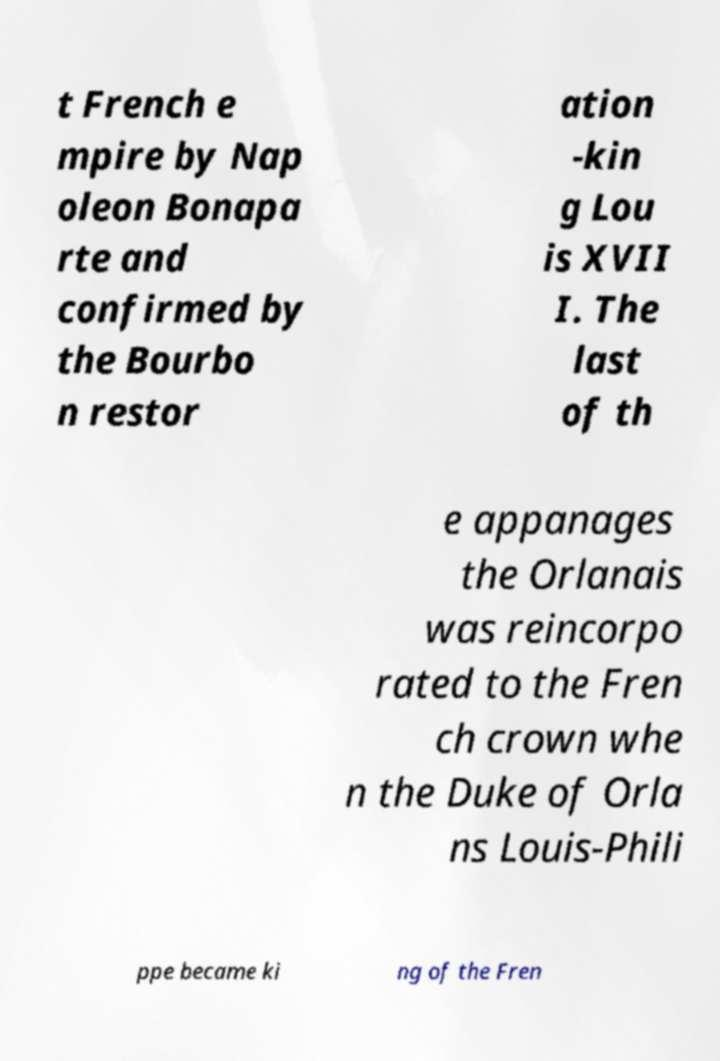Can you accurately transcribe the text from the provided image for me? t French e mpire by Nap oleon Bonapa rte and confirmed by the Bourbo n restor ation -kin g Lou is XVII I. The last of th e appanages the Orlanais was reincorpo rated to the Fren ch crown whe n the Duke of Orla ns Louis-Phili ppe became ki ng of the Fren 